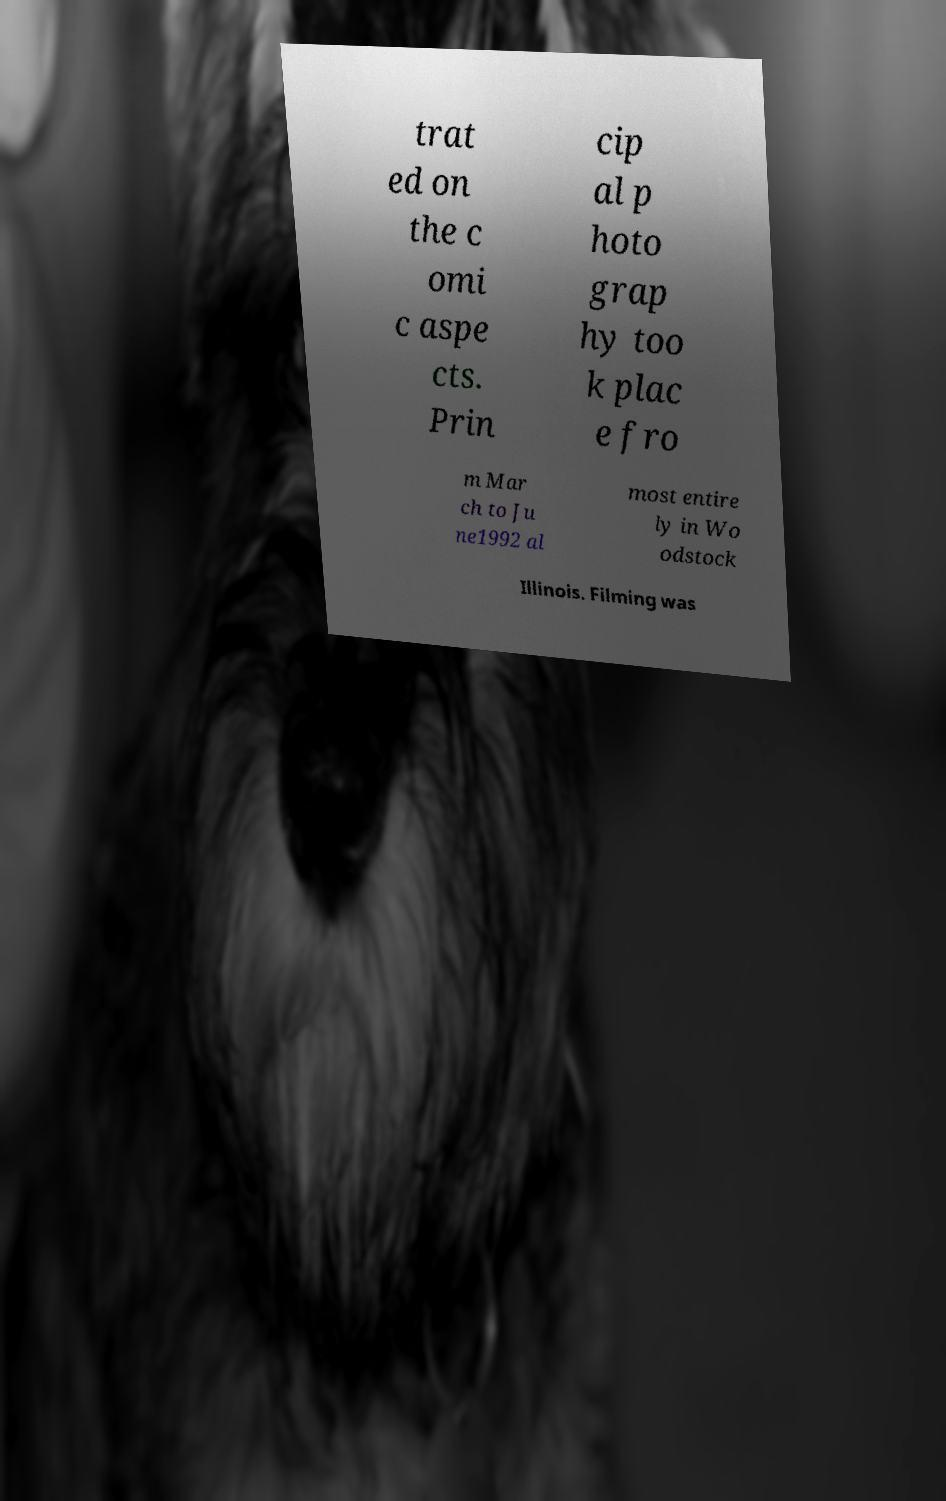Please identify and transcribe the text found in this image. trat ed on the c omi c aspe cts. Prin cip al p hoto grap hy too k plac e fro m Mar ch to Ju ne1992 al most entire ly in Wo odstock Illinois. Filming was 